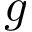<formula> <loc_0><loc_0><loc_500><loc_500>g</formula> 